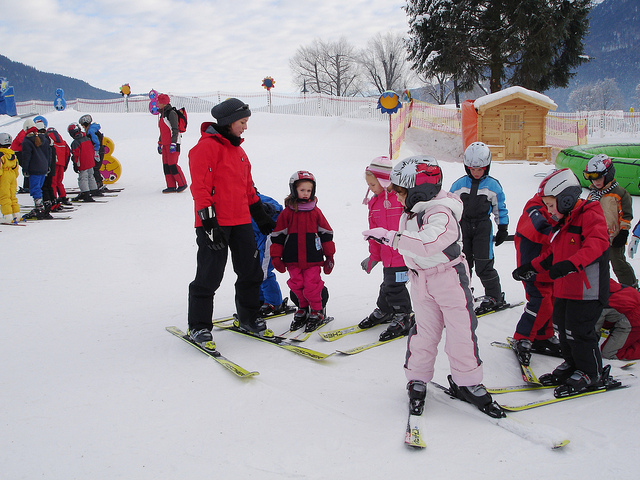<image>How deep is the snow? I don't know how deep the snow is. It could range from a few inches to a foot. How deep is the snow? I don't know how deep the snow is. It can be 1 foot, 3 inches, or 2 feet. 